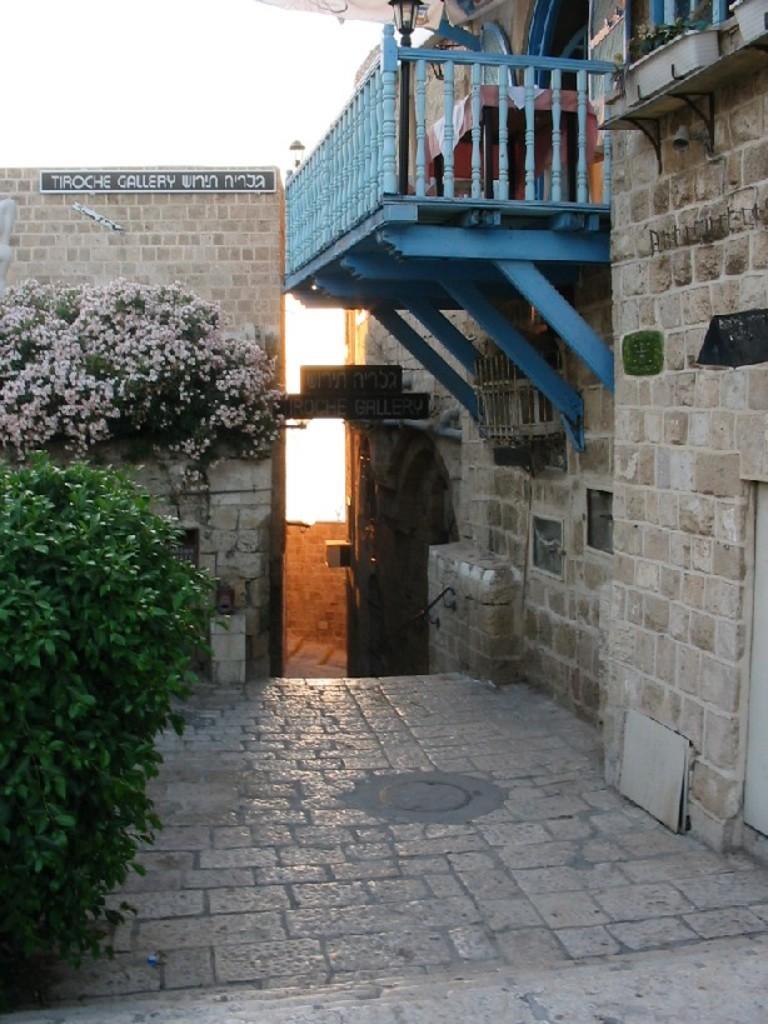Could you give a brief overview of what you see in this image? On the left side of the image there are some plants and flowers. Behind the plants there is wall. On the right side of the image there is a building. 